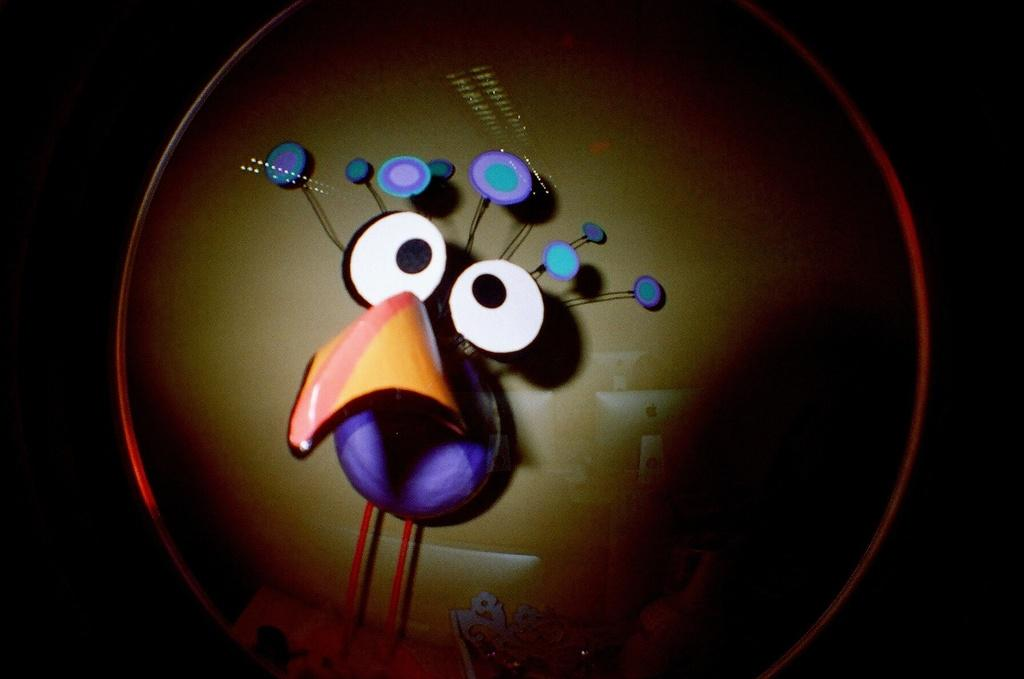What type of image is shown in the picture? The image contains a cartoon picture. Can you describe the background of the cartoon picture? There are systems visible in the background of the image. What type of fowl can be seen in the image? There is no fowl present in the image; it contains a cartoon picture with systems in the background. What smell is associated with the image? There is no smell associated with the image, as it is a visual representation. 